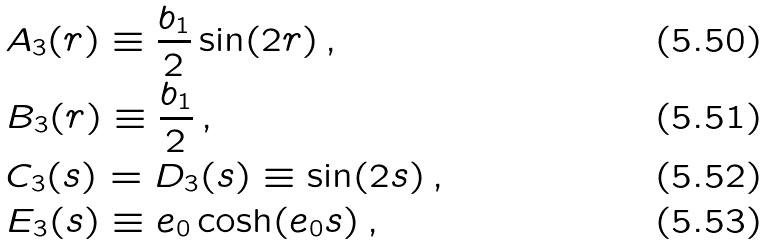Convert formula to latex. <formula><loc_0><loc_0><loc_500><loc_500>& A _ { 3 } ( r ) \equiv \frac { b _ { 1 } } { 2 } \sin ( 2 r ) \, , \\ & B _ { 3 } ( r ) \equiv \frac { b _ { 1 } } { 2 } \, , \\ & C _ { 3 } ( s ) = D _ { 3 } ( s ) \equiv \sin ( 2 s ) \, , \\ & E _ { 3 } ( s ) \equiv e _ { 0 } \cosh ( e _ { 0 } s ) \, ,</formula> 